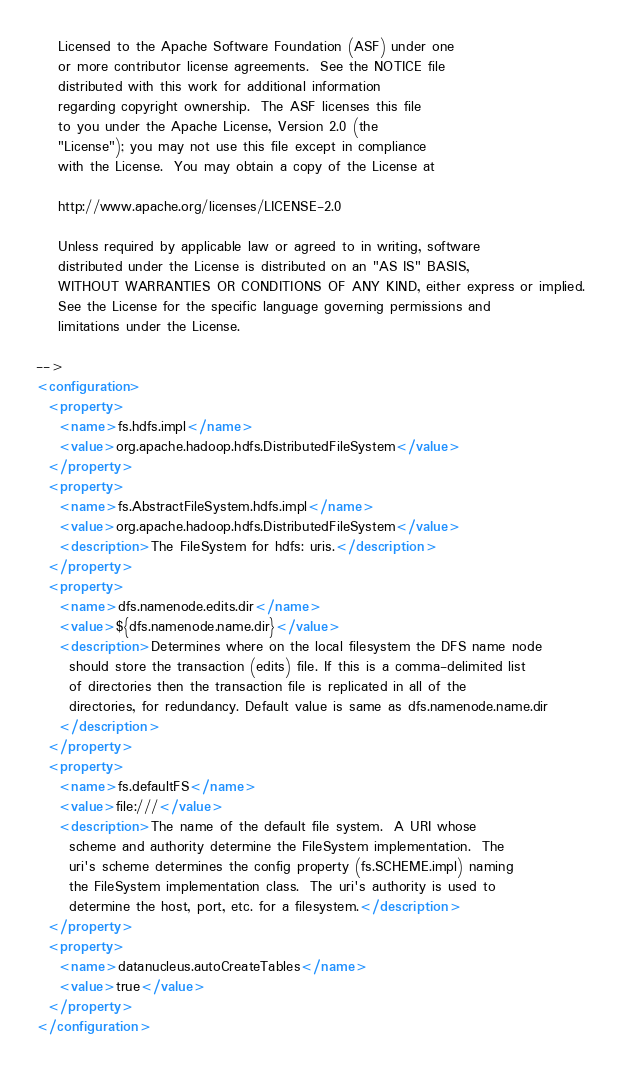Convert code to text. <code><loc_0><loc_0><loc_500><loc_500><_XML_>
    Licensed to the Apache Software Foundation (ASF) under one
    or more contributor license agreements.  See the NOTICE file
    distributed with this work for additional information
    regarding copyright ownership.  The ASF licenses this file
    to you under the Apache License, Version 2.0 (the
    "License"); you may not use this file except in compliance
    with the License.  You may obtain a copy of the License at

    http://www.apache.org/licenses/LICENSE-2.0

    Unless required by applicable law or agreed to in writing, software
    distributed under the License is distributed on an "AS IS" BASIS,
    WITHOUT WARRANTIES OR CONDITIONS OF ANY KIND, either express or implied.
    See the License for the specific language governing permissions and
    limitations under the License.

-->
<configuration>
  <property>
    <name>fs.hdfs.impl</name>
    <value>org.apache.hadoop.hdfs.DistributedFileSystem</value>
  </property>
  <property>
    <name>fs.AbstractFileSystem.hdfs.impl</name>
    <value>org.apache.hadoop.hdfs.DistributedFileSystem</value>
    <description>The FileSystem for hdfs: uris.</description>
  </property>
  <property>
    <name>dfs.namenode.edits.dir</name>
    <value>${dfs.namenode.name.dir}</value>
    <description>Determines where on the local filesystem the DFS name node
      should store the transaction (edits) file. If this is a comma-delimited list
      of directories then the transaction file is replicated in all of the
      directories, for redundancy. Default value is same as dfs.namenode.name.dir
    </description>
  </property>
  <property>
    <name>fs.defaultFS</name>
    <value>file:///</value>
    <description>The name of the default file system.  A URI whose
      scheme and authority determine the FileSystem implementation.  The
      uri's scheme determines the config property (fs.SCHEME.impl) naming
      the FileSystem implementation class.  The uri's authority is used to
      determine the host, port, etc. for a filesystem.</description>
  </property>
  <property>
    <name>datanucleus.autoCreateTables</name>
    <value>true</value>
  </property>
</configuration></code> 